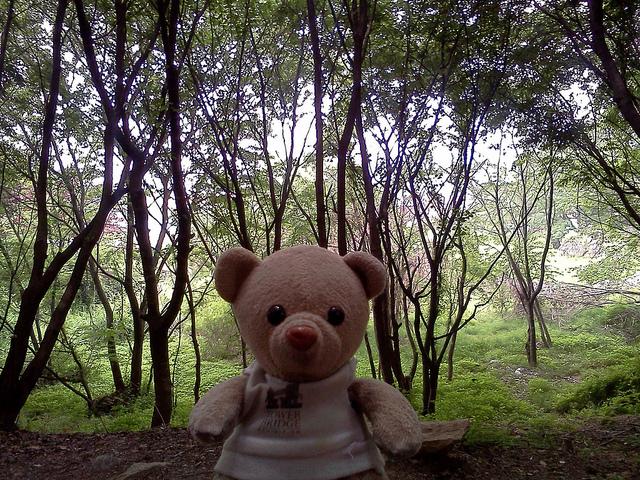Is this outdoors?
Answer briefly. Yes. Is the bear real?
Keep it brief. No. Does this animal growl?
Be succinct. No. What color is the bear's nose?
Short answer required. Brown. Does this animal have claws?
Answer briefly. No. What color is the teddy bears shirt?
Give a very brief answer. White. Is this animal barely clothed?
Keep it brief. No. What kind of bear is pictured?
Short answer required. Teddy. 